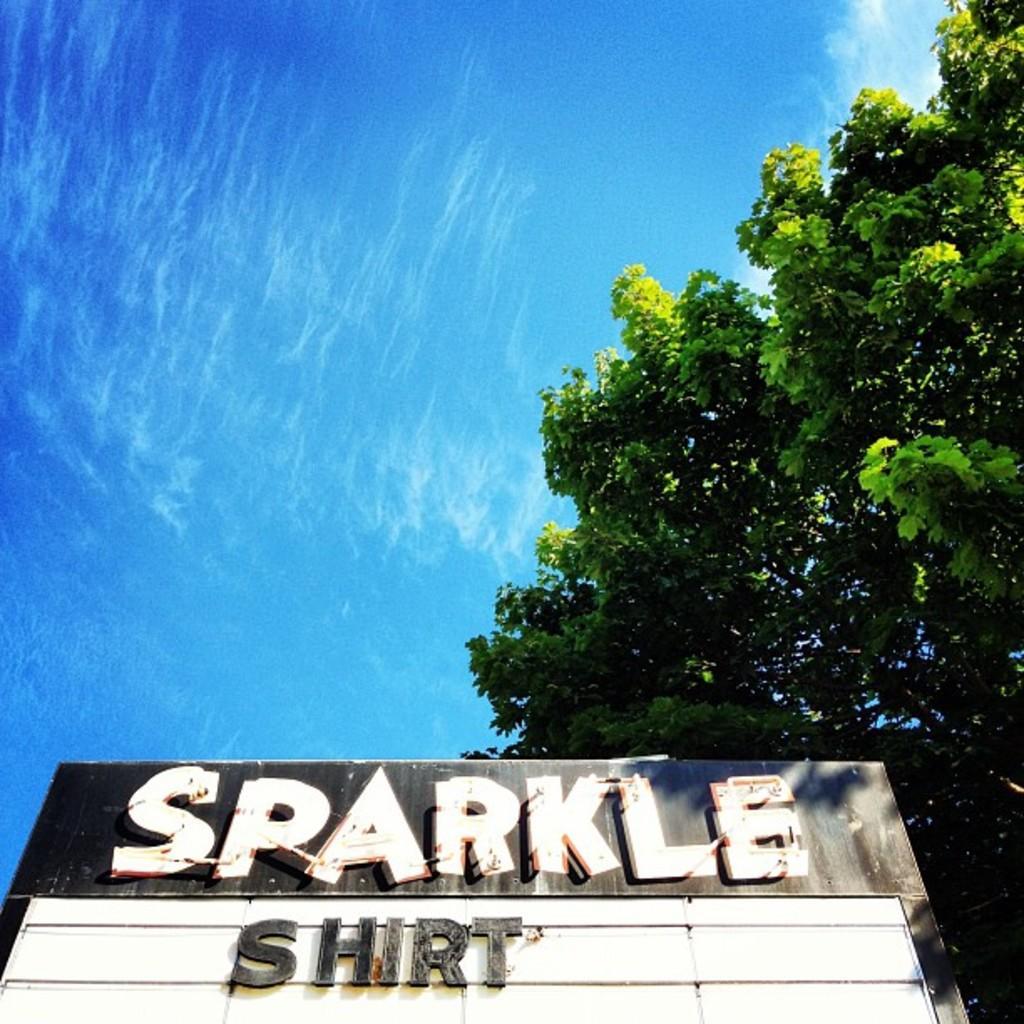Could you give a brief overview of what you see in this image? In this image I can see the board in black and white color. In the background I can see few trees in green color and the sky is in blue and white color. 